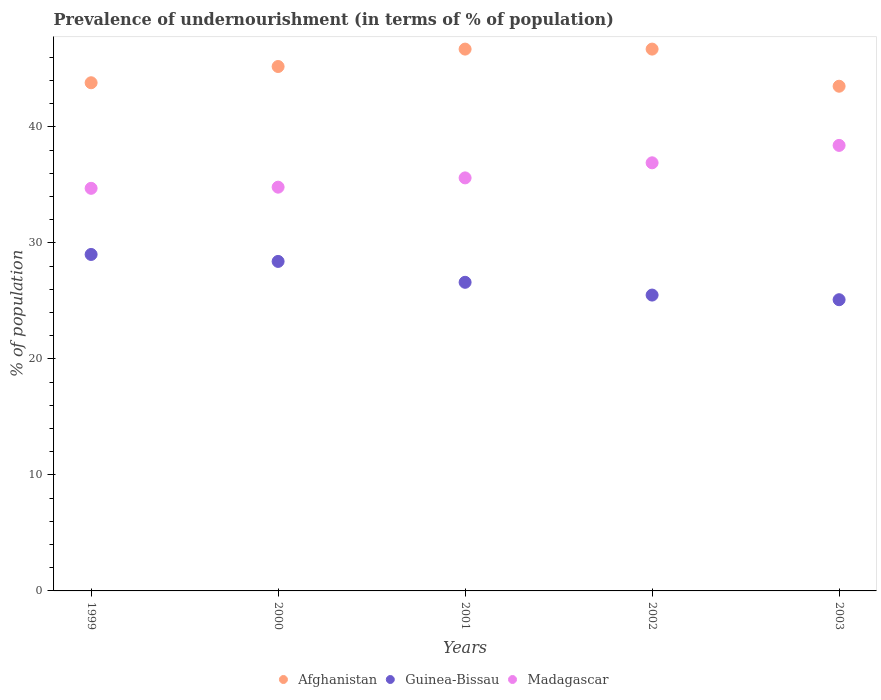How many different coloured dotlines are there?
Provide a succinct answer. 3. Across all years, what is the maximum percentage of undernourished population in Afghanistan?
Give a very brief answer. 46.7. Across all years, what is the minimum percentage of undernourished population in Afghanistan?
Your answer should be very brief. 43.5. In which year was the percentage of undernourished population in Afghanistan minimum?
Make the answer very short. 2003. What is the total percentage of undernourished population in Guinea-Bissau in the graph?
Your response must be concise. 134.6. What is the difference between the percentage of undernourished population in Afghanistan in 2000 and that in 2003?
Provide a succinct answer. 1.7. What is the difference between the percentage of undernourished population in Madagascar in 2002 and the percentage of undernourished population in Afghanistan in 1999?
Give a very brief answer. -6.9. What is the average percentage of undernourished population in Guinea-Bissau per year?
Offer a very short reply. 26.92. In the year 1999, what is the difference between the percentage of undernourished population in Afghanistan and percentage of undernourished population in Madagascar?
Make the answer very short. 9.1. In how many years, is the percentage of undernourished population in Madagascar greater than 20 %?
Offer a terse response. 5. What is the ratio of the percentage of undernourished population in Guinea-Bissau in 2002 to that in 2003?
Give a very brief answer. 1.02. Is the difference between the percentage of undernourished population in Afghanistan in 2002 and 2003 greater than the difference between the percentage of undernourished population in Madagascar in 2002 and 2003?
Provide a short and direct response. Yes. What is the difference between the highest and the lowest percentage of undernourished population in Afghanistan?
Keep it short and to the point. 3.2. Is the percentage of undernourished population in Guinea-Bissau strictly greater than the percentage of undernourished population in Madagascar over the years?
Offer a terse response. No. How many dotlines are there?
Your answer should be very brief. 3. How many years are there in the graph?
Provide a succinct answer. 5. Does the graph contain any zero values?
Offer a terse response. No. Does the graph contain grids?
Your answer should be very brief. No. How many legend labels are there?
Your response must be concise. 3. How are the legend labels stacked?
Your answer should be very brief. Horizontal. What is the title of the graph?
Offer a terse response. Prevalence of undernourishment (in terms of % of population). What is the label or title of the X-axis?
Make the answer very short. Years. What is the label or title of the Y-axis?
Keep it short and to the point. % of population. What is the % of population in Afghanistan in 1999?
Give a very brief answer. 43.8. What is the % of population of Guinea-Bissau in 1999?
Offer a terse response. 29. What is the % of population in Madagascar in 1999?
Your response must be concise. 34.7. What is the % of population in Afghanistan in 2000?
Your answer should be compact. 45.2. What is the % of population of Guinea-Bissau in 2000?
Your answer should be compact. 28.4. What is the % of population in Madagascar in 2000?
Your answer should be very brief. 34.8. What is the % of population of Afghanistan in 2001?
Keep it short and to the point. 46.7. What is the % of population in Guinea-Bissau in 2001?
Your response must be concise. 26.6. What is the % of population in Madagascar in 2001?
Offer a very short reply. 35.6. What is the % of population of Afghanistan in 2002?
Give a very brief answer. 46.7. What is the % of population in Madagascar in 2002?
Keep it short and to the point. 36.9. What is the % of population in Afghanistan in 2003?
Your response must be concise. 43.5. What is the % of population of Guinea-Bissau in 2003?
Offer a very short reply. 25.1. What is the % of population in Madagascar in 2003?
Provide a short and direct response. 38.4. Across all years, what is the maximum % of population of Afghanistan?
Your answer should be very brief. 46.7. Across all years, what is the maximum % of population of Madagascar?
Give a very brief answer. 38.4. Across all years, what is the minimum % of population of Afghanistan?
Ensure brevity in your answer.  43.5. Across all years, what is the minimum % of population in Guinea-Bissau?
Give a very brief answer. 25.1. Across all years, what is the minimum % of population in Madagascar?
Keep it short and to the point. 34.7. What is the total % of population of Afghanistan in the graph?
Provide a succinct answer. 225.9. What is the total % of population of Guinea-Bissau in the graph?
Offer a terse response. 134.6. What is the total % of population in Madagascar in the graph?
Your answer should be very brief. 180.4. What is the difference between the % of population in Afghanistan in 1999 and that in 2000?
Provide a succinct answer. -1.4. What is the difference between the % of population of Guinea-Bissau in 1999 and that in 2000?
Ensure brevity in your answer.  0.6. What is the difference between the % of population of Madagascar in 1999 and that in 2000?
Make the answer very short. -0.1. What is the difference between the % of population of Afghanistan in 1999 and that in 2001?
Give a very brief answer. -2.9. What is the difference between the % of population of Guinea-Bissau in 1999 and that in 2001?
Your answer should be compact. 2.4. What is the difference between the % of population of Madagascar in 1999 and that in 2001?
Provide a succinct answer. -0.9. What is the difference between the % of population of Afghanistan in 1999 and that in 2002?
Offer a terse response. -2.9. What is the difference between the % of population of Guinea-Bissau in 1999 and that in 2002?
Offer a terse response. 3.5. What is the difference between the % of population of Madagascar in 1999 and that in 2002?
Provide a short and direct response. -2.2. What is the difference between the % of population of Afghanistan in 1999 and that in 2003?
Keep it short and to the point. 0.3. What is the difference between the % of population in Madagascar in 1999 and that in 2003?
Give a very brief answer. -3.7. What is the difference between the % of population of Afghanistan in 2000 and that in 2002?
Your answer should be very brief. -1.5. What is the difference between the % of population of Guinea-Bissau in 2000 and that in 2002?
Your response must be concise. 2.9. What is the difference between the % of population in Madagascar in 2000 and that in 2002?
Provide a succinct answer. -2.1. What is the difference between the % of population in Afghanistan in 2000 and that in 2003?
Your answer should be compact. 1.7. What is the difference between the % of population of Madagascar in 2000 and that in 2003?
Make the answer very short. -3.6. What is the difference between the % of population in Afghanistan in 2001 and that in 2003?
Offer a terse response. 3.2. What is the difference between the % of population in Guinea-Bissau in 2001 and that in 2003?
Ensure brevity in your answer.  1.5. What is the difference between the % of population of Guinea-Bissau in 2002 and that in 2003?
Make the answer very short. 0.4. What is the difference between the % of population in Madagascar in 2002 and that in 2003?
Provide a short and direct response. -1.5. What is the difference between the % of population in Afghanistan in 1999 and the % of population in Guinea-Bissau in 2000?
Ensure brevity in your answer.  15.4. What is the difference between the % of population of Afghanistan in 1999 and the % of population of Guinea-Bissau in 2001?
Provide a succinct answer. 17.2. What is the difference between the % of population of Afghanistan in 1999 and the % of population of Madagascar in 2001?
Give a very brief answer. 8.2. What is the difference between the % of population of Afghanistan in 1999 and the % of population of Guinea-Bissau in 2003?
Your response must be concise. 18.7. What is the difference between the % of population of Guinea-Bissau in 1999 and the % of population of Madagascar in 2003?
Provide a succinct answer. -9.4. What is the difference between the % of population of Guinea-Bissau in 2000 and the % of population of Madagascar in 2001?
Give a very brief answer. -7.2. What is the difference between the % of population of Afghanistan in 2000 and the % of population of Guinea-Bissau in 2002?
Provide a short and direct response. 19.7. What is the difference between the % of population of Guinea-Bissau in 2000 and the % of population of Madagascar in 2002?
Your response must be concise. -8.5. What is the difference between the % of population in Afghanistan in 2000 and the % of population in Guinea-Bissau in 2003?
Make the answer very short. 20.1. What is the difference between the % of population in Guinea-Bissau in 2000 and the % of population in Madagascar in 2003?
Offer a very short reply. -10. What is the difference between the % of population of Afghanistan in 2001 and the % of population of Guinea-Bissau in 2002?
Your answer should be compact. 21.2. What is the difference between the % of population in Afghanistan in 2001 and the % of population in Madagascar in 2002?
Provide a short and direct response. 9.8. What is the difference between the % of population of Guinea-Bissau in 2001 and the % of population of Madagascar in 2002?
Your answer should be compact. -10.3. What is the difference between the % of population of Afghanistan in 2001 and the % of population of Guinea-Bissau in 2003?
Offer a very short reply. 21.6. What is the difference between the % of population of Afghanistan in 2001 and the % of population of Madagascar in 2003?
Your answer should be compact. 8.3. What is the difference between the % of population of Guinea-Bissau in 2001 and the % of population of Madagascar in 2003?
Keep it short and to the point. -11.8. What is the difference between the % of population in Afghanistan in 2002 and the % of population in Guinea-Bissau in 2003?
Your response must be concise. 21.6. What is the average % of population in Afghanistan per year?
Your answer should be compact. 45.18. What is the average % of population of Guinea-Bissau per year?
Ensure brevity in your answer.  26.92. What is the average % of population in Madagascar per year?
Offer a terse response. 36.08. In the year 1999, what is the difference between the % of population in Afghanistan and % of population in Guinea-Bissau?
Offer a very short reply. 14.8. In the year 1999, what is the difference between the % of population in Guinea-Bissau and % of population in Madagascar?
Offer a terse response. -5.7. In the year 2000, what is the difference between the % of population in Afghanistan and % of population in Guinea-Bissau?
Give a very brief answer. 16.8. In the year 2001, what is the difference between the % of population in Afghanistan and % of population in Guinea-Bissau?
Your answer should be compact. 20.1. In the year 2001, what is the difference between the % of population of Afghanistan and % of population of Madagascar?
Provide a succinct answer. 11.1. In the year 2002, what is the difference between the % of population of Afghanistan and % of population of Guinea-Bissau?
Offer a terse response. 21.2. In the year 2002, what is the difference between the % of population of Afghanistan and % of population of Madagascar?
Your response must be concise. 9.8. In the year 2003, what is the difference between the % of population of Afghanistan and % of population of Guinea-Bissau?
Offer a very short reply. 18.4. In the year 2003, what is the difference between the % of population of Afghanistan and % of population of Madagascar?
Your response must be concise. 5.1. In the year 2003, what is the difference between the % of population in Guinea-Bissau and % of population in Madagascar?
Your response must be concise. -13.3. What is the ratio of the % of population of Afghanistan in 1999 to that in 2000?
Your answer should be compact. 0.97. What is the ratio of the % of population of Guinea-Bissau in 1999 to that in 2000?
Give a very brief answer. 1.02. What is the ratio of the % of population in Madagascar in 1999 to that in 2000?
Provide a short and direct response. 1. What is the ratio of the % of population of Afghanistan in 1999 to that in 2001?
Ensure brevity in your answer.  0.94. What is the ratio of the % of population in Guinea-Bissau in 1999 to that in 2001?
Keep it short and to the point. 1.09. What is the ratio of the % of population in Madagascar in 1999 to that in 2001?
Keep it short and to the point. 0.97. What is the ratio of the % of population of Afghanistan in 1999 to that in 2002?
Your response must be concise. 0.94. What is the ratio of the % of population in Guinea-Bissau in 1999 to that in 2002?
Offer a terse response. 1.14. What is the ratio of the % of population of Madagascar in 1999 to that in 2002?
Your answer should be compact. 0.94. What is the ratio of the % of population of Afghanistan in 1999 to that in 2003?
Provide a succinct answer. 1.01. What is the ratio of the % of population in Guinea-Bissau in 1999 to that in 2003?
Give a very brief answer. 1.16. What is the ratio of the % of population of Madagascar in 1999 to that in 2003?
Ensure brevity in your answer.  0.9. What is the ratio of the % of population of Afghanistan in 2000 to that in 2001?
Make the answer very short. 0.97. What is the ratio of the % of population of Guinea-Bissau in 2000 to that in 2001?
Ensure brevity in your answer.  1.07. What is the ratio of the % of population in Madagascar in 2000 to that in 2001?
Make the answer very short. 0.98. What is the ratio of the % of population of Afghanistan in 2000 to that in 2002?
Keep it short and to the point. 0.97. What is the ratio of the % of population in Guinea-Bissau in 2000 to that in 2002?
Offer a very short reply. 1.11. What is the ratio of the % of population in Madagascar in 2000 to that in 2002?
Your answer should be very brief. 0.94. What is the ratio of the % of population of Afghanistan in 2000 to that in 2003?
Make the answer very short. 1.04. What is the ratio of the % of population in Guinea-Bissau in 2000 to that in 2003?
Your response must be concise. 1.13. What is the ratio of the % of population in Madagascar in 2000 to that in 2003?
Keep it short and to the point. 0.91. What is the ratio of the % of population in Afghanistan in 2001 to that in 2002?
Ensure brevity in your answer.  1. What is the ratio of the % of population of Guinea-Bissau in 2001 to that in 2002?
Your answer should be very brief. 1.04. What is the ratio of the % of population of Madagascar in 2001 to that in 2002?
Your answer should be very brief. 0.96. What is the ratio of the % of population of Afghanistan in 2001 to that in 2003?
Give a very brief answer. 1.07. What is the ratio of the % of population of Guinea-Bissau in 2001 to that in 2003?
Provide a short and direct response. 1.06. What is the ratio of the % of population of Madagascar in 2001 to that in 2003?
Your answer should be compact. 0.93. What is the ratio of the % of population of Afghanistan in 2002 to that in 2003?
Offer a very short reply. 1.07. What is the ratio of the % of population in Guinea-Bissau in 2002 to that in 2003?
Your answer should be compact. 1.02. What is the ratio of the % of population in Madagascar in 2002 to that in 2003?
Make the answer very short. 0.96. What is the difference between the highest and the second highest % of population in Madagascar?
Offer a very short reply. 1.5. What is the difference between the highest and the lowest % of population in Afghanistan?
Provide a short and direct response. 3.2. What is the difference between the highest and the lowest % of population of Guinea-Bissau?
Your response must be concise. 3.9. 